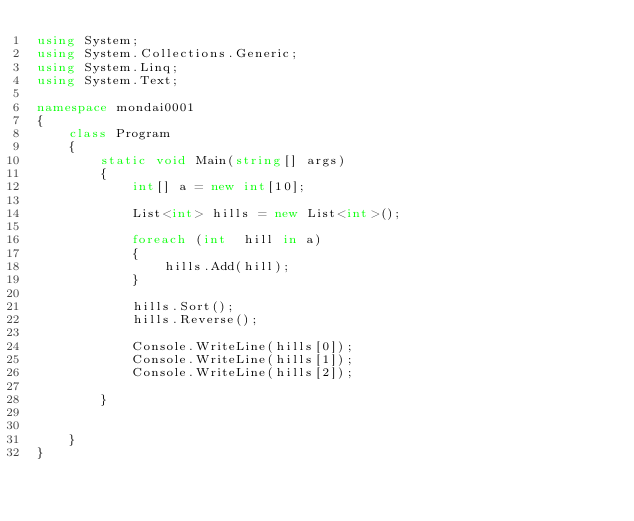<code> <loc_0><loc_0><loc_500><loc_500><_C#_>using System;
using System.Collections.Generic;
using System.Linq;
using System.Text;

namespace mondai0001
{
    class Program
    {
        static void Main(string[] args)
        {
            int[] a = new int[10];

            List<int> hills = new List<int>();

            foreach (int  hill in a)
            {
                hills.Add(hill);
            }

            hills.Sort();
            hills.Reverse();

            Console.WriteLine(hills[0]);
            Console.WriteLine(hills[1]);
            Console.WriteLine(hills[2]);

        }

        
    }
}</code> 